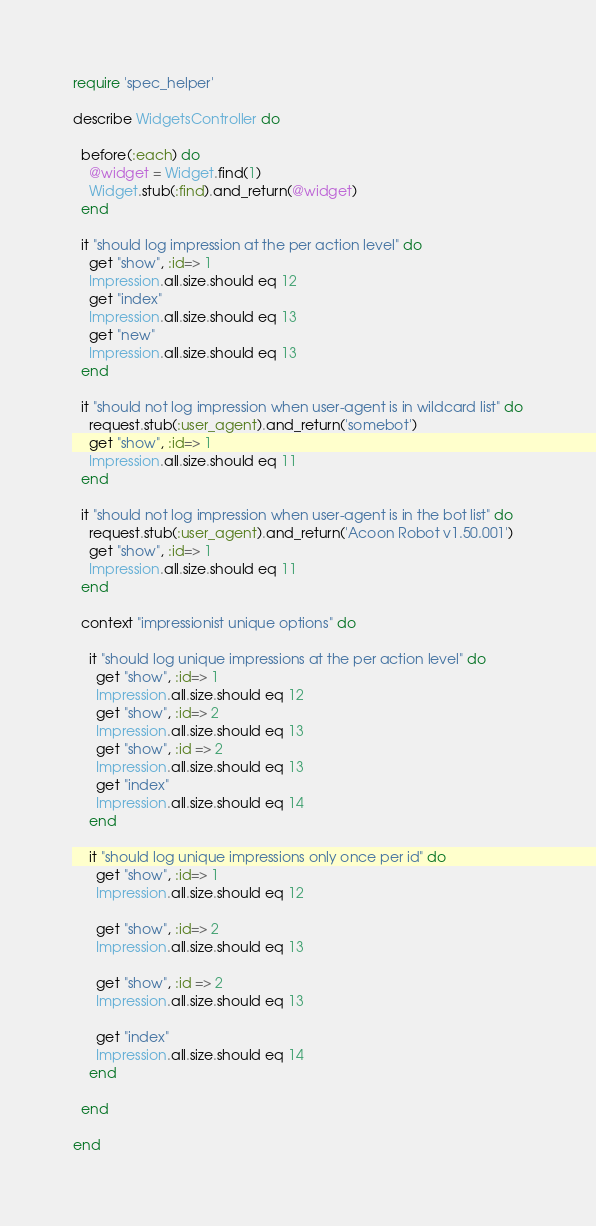<code> <loc_0><loc_0><loc_500><loc_500><_Ruby_>require 'spec_helper'

describe WidgetsController do

  before(:each) do
    @widget = Widget.find(1)
    Widget.stub(:find).and_return(@widget)
  end

  it "should log impression at the per action level" do
    get "show", :id=> 1
    Impression.all.size.should eq 12
    get "index"
    Impression.all.size.should eq 13
    get "new"
    Impression.all.size.should eq 13
  end

  it "should not log impression when user-agent is in wildcard list" do
    request.stub(:user_agent).and_return('somebot')
    get "show", :id=> 1
    Impression.all.size.should eq 11
  end

  it "should not log impression when user-agent is in the bot list" do
    request.stub(:user_agent).and_return('Acoon Robot v1.50.001')
    get "show", :id=> 1
    Impression.all.size.should eq 11
  end

  context "impressionist unique options" do

    it "should log unique impressions at the per action level" do
      get "show", :id=> 1
      Impression.all.size.should eq 12
      get "show", :id=> 2
      Impression.all.size.should eq 13
      get "show", :id => 2
      Impression.all.size.should eq 13
      get "index"
      Impression.all.size.should eq 14
    end

    it "should log unique impressions only once per id" do
      get "show", :id=> 1
      Impression.all.size.should eq 12

      get "show", :id=> 2
      Impression.all.size.should eq 13

      get "show", :id => 2
      Impression.all.size.should eq 13

      get "index"
      Impression.all.size.should eq 14
    end

  end

end
</code> 